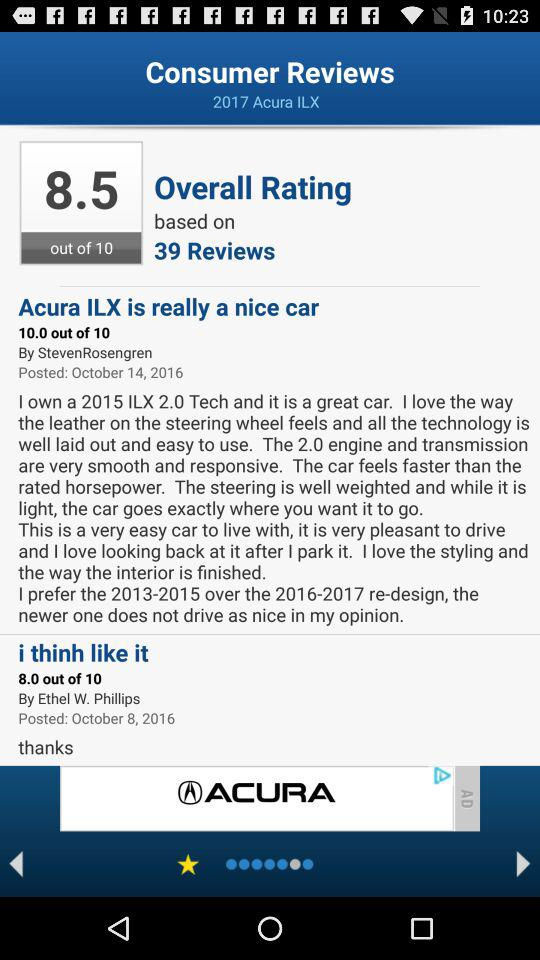How many out of 10 did the review "Acura ILX is really a nice car" get? The review "Acura ILX is really a nice car" got a 10 out of 10. 